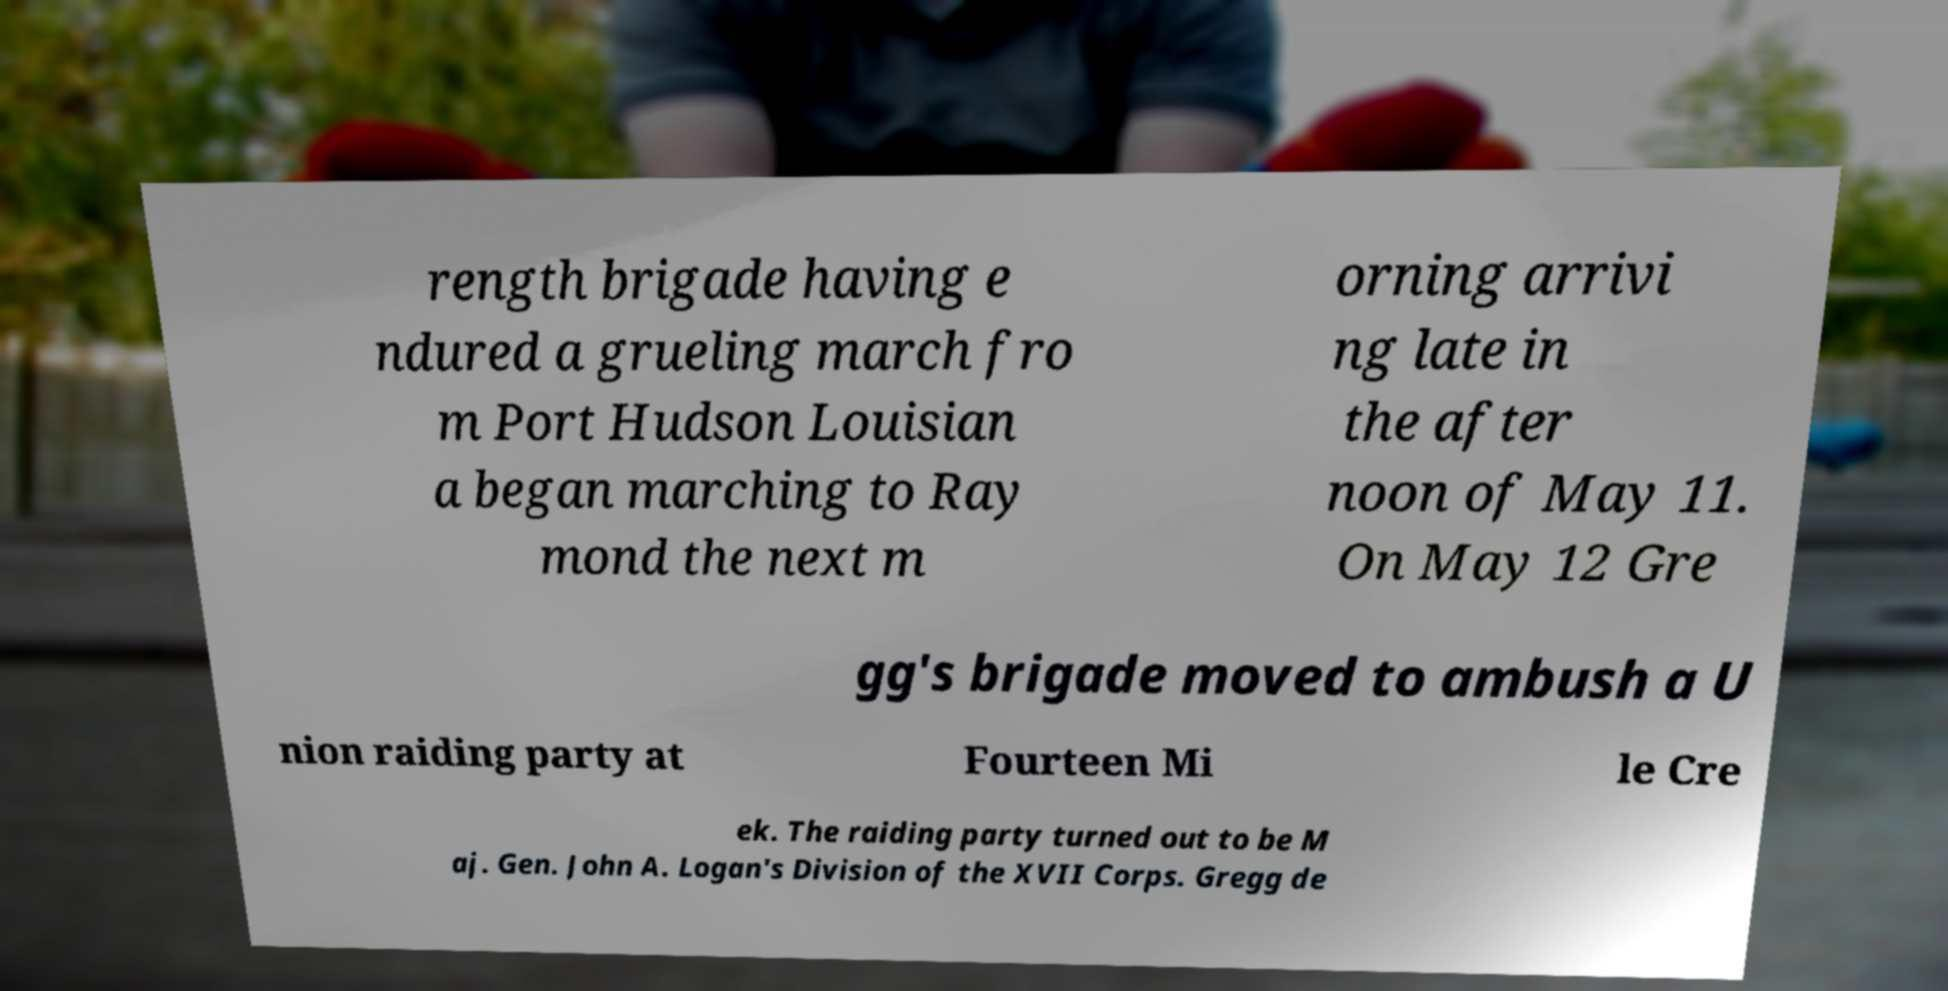Please identify and transcribe the text found in this image. rength brigade having e ndured a grueling march fro m Port Hudson Louisian a began marching to Ray mond the next m orning arrivi ng late in the after noon of May 11. On May 12 Gre gg's brigade moved to ambush a U nion raiding party at Fourteen Mi le Cre ek. The raiding party turned out to be M aj. Gen. John A. Logan's Division of the XVII Corps. Gregg de 